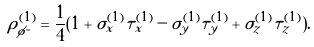<formula> <loc_0><loc_0><loc_500><loc_500>\rho ^ { ( 1 ) } _ { \phi ^ { = } } = \frac { 1 } { 4 } ( 1 + \sigma _ { x } ^ { ( 1 ) } \tau _ { x } ^ { ( 1 ) } - \sigma _ { y } ^ { ( 1 ) } \tau _ { y } ^ { ( 1 ) } + \sigma _ { z } ^ { ( 1 ) } \tau _ { z } ^ { ( 1 ) } ) .</formula> 